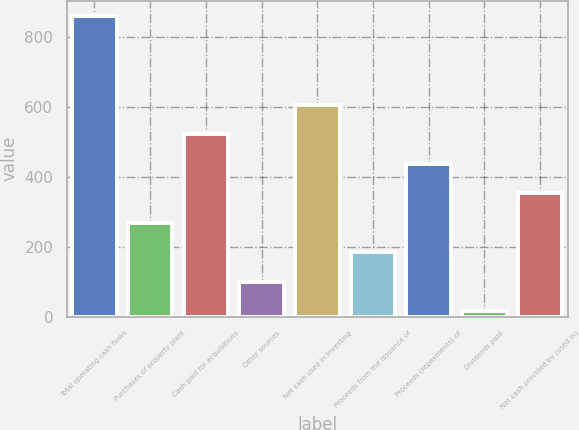<chart> <loc_0><loc_0><loc_500><loc_500><bar_chart><fcel>Total operating cash flows<fcel>Purchases of property plant<fcel>Cash paid for acquisitions<fcel>Other sources<fcel>Net cash used in investing<fcel>Proceeds from the issuance of<fcel>Proceeds (repayments) of<fcel>Dividends paid<fcel>Net cash provided by (used in)<nl><fcel>861.5<fcel>269.16<fcel>523.02<fcel>99.92<fcel>607.64<fcel>184.54<fcel>438.4<fcel>15.3<fcel>353.78<nl></chart> 